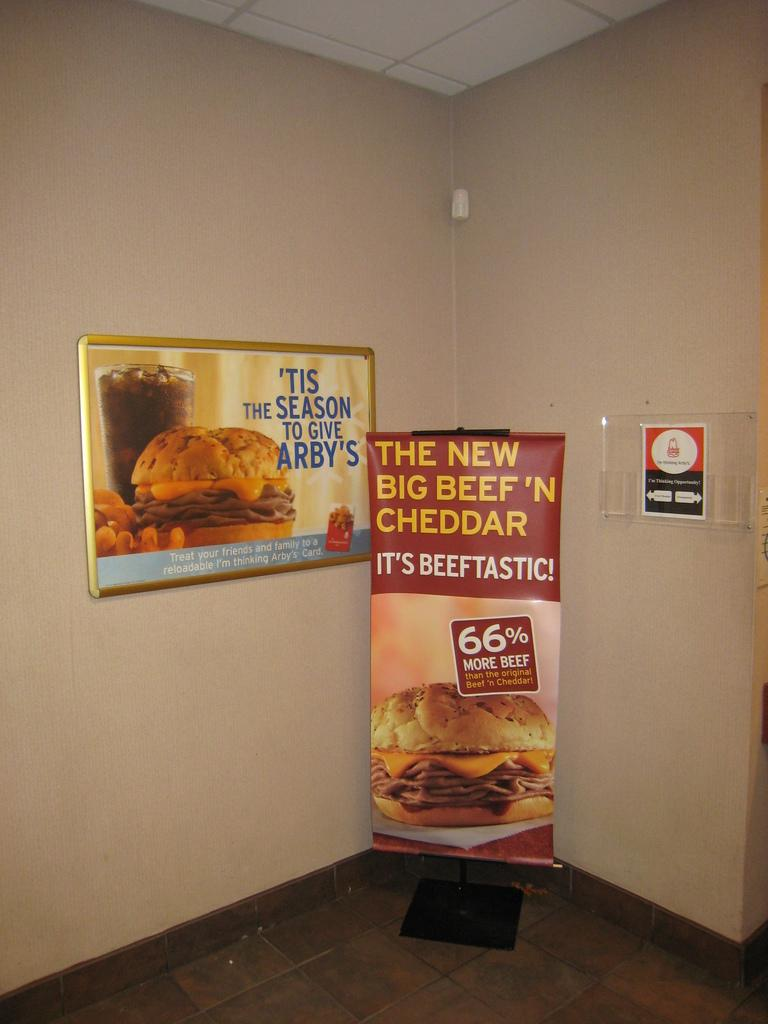What is hanging in the image? There is a banner in the image. What is depicted on the banner? The banner has an image on it. What information is provided on the banner? The banner has text written on it. What can be seen in the background of the image? There is a wall in the background of the image. What objects are attached to the wall? There is a glass and a board attached to the wall. What type of education can be seen taking place in the alley behind the wall in the image? There is no education or alley present in the image; it only features a banner, a wall, and objects attached to the wall. 